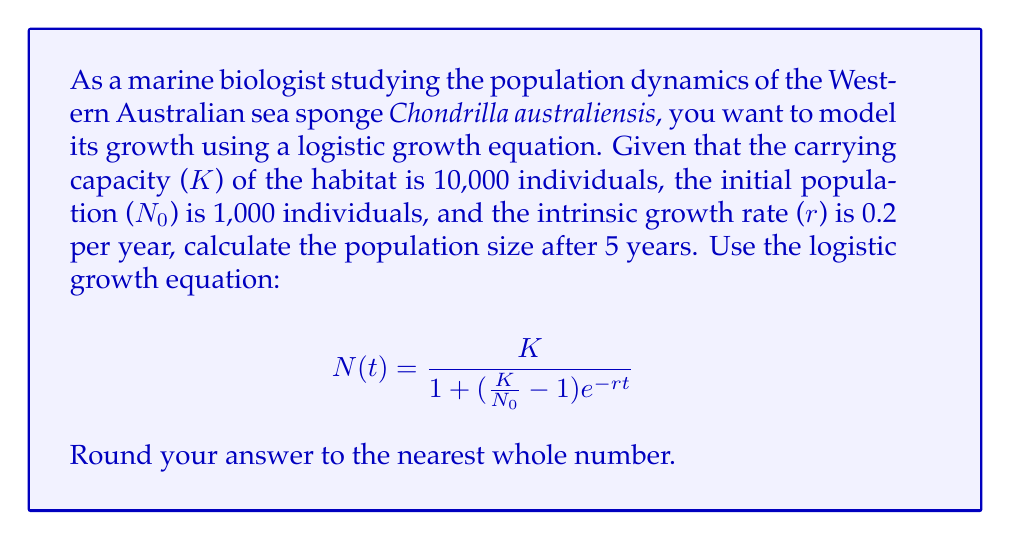Can you solve this math problem? To solve this problem, we'll follow these steps:

1. Identify the given parameters:
   - Carrying capacity (K) = 10,000 individuals
   - Initial population (N₀) = 1,000 individuals
   - Intrinsic growth rate (r) = 0.2 per year
   - Time (t) = 5 years

2. Substitute these values into the logistic growth equation:

   $$N(5) = \frac{10000}{1 + (\frac{10000}{1000} - 1)e^{-0.2 \cdot 5}}$$

3. Simplify the expression inside the parentheses:
   $$\frac{10000}{1000} - 1 = 10 - 1 = 9$$

4. Calculate the exponent:
   $$-0.2 \cdot 5 = -1$$

5. Simplify the equation:
   $$N(5) = \frac{10000}{1 + 9e^{-1}}$$

6. Calculate $e^{-1}$:
   $$e^{-1} \approx 0.3679$$

7. Substitute this value:
   $$N(5) = \frac{10000}{1 + 9 \cdot 0.3679} = \frac{10000}{1 + 3.3111}$$

8. Perform the division:
   $$N(5) = \frac{10000}{4.3111} \approx 2319.59$$

9. Round to the nearest whole number:
   $$N(5) \approx 2320$$

Therefore, the population size of Chondrilla australiensis after 5 years will be approximately 2,320 individuals.
Answer: 2,320 individuals 